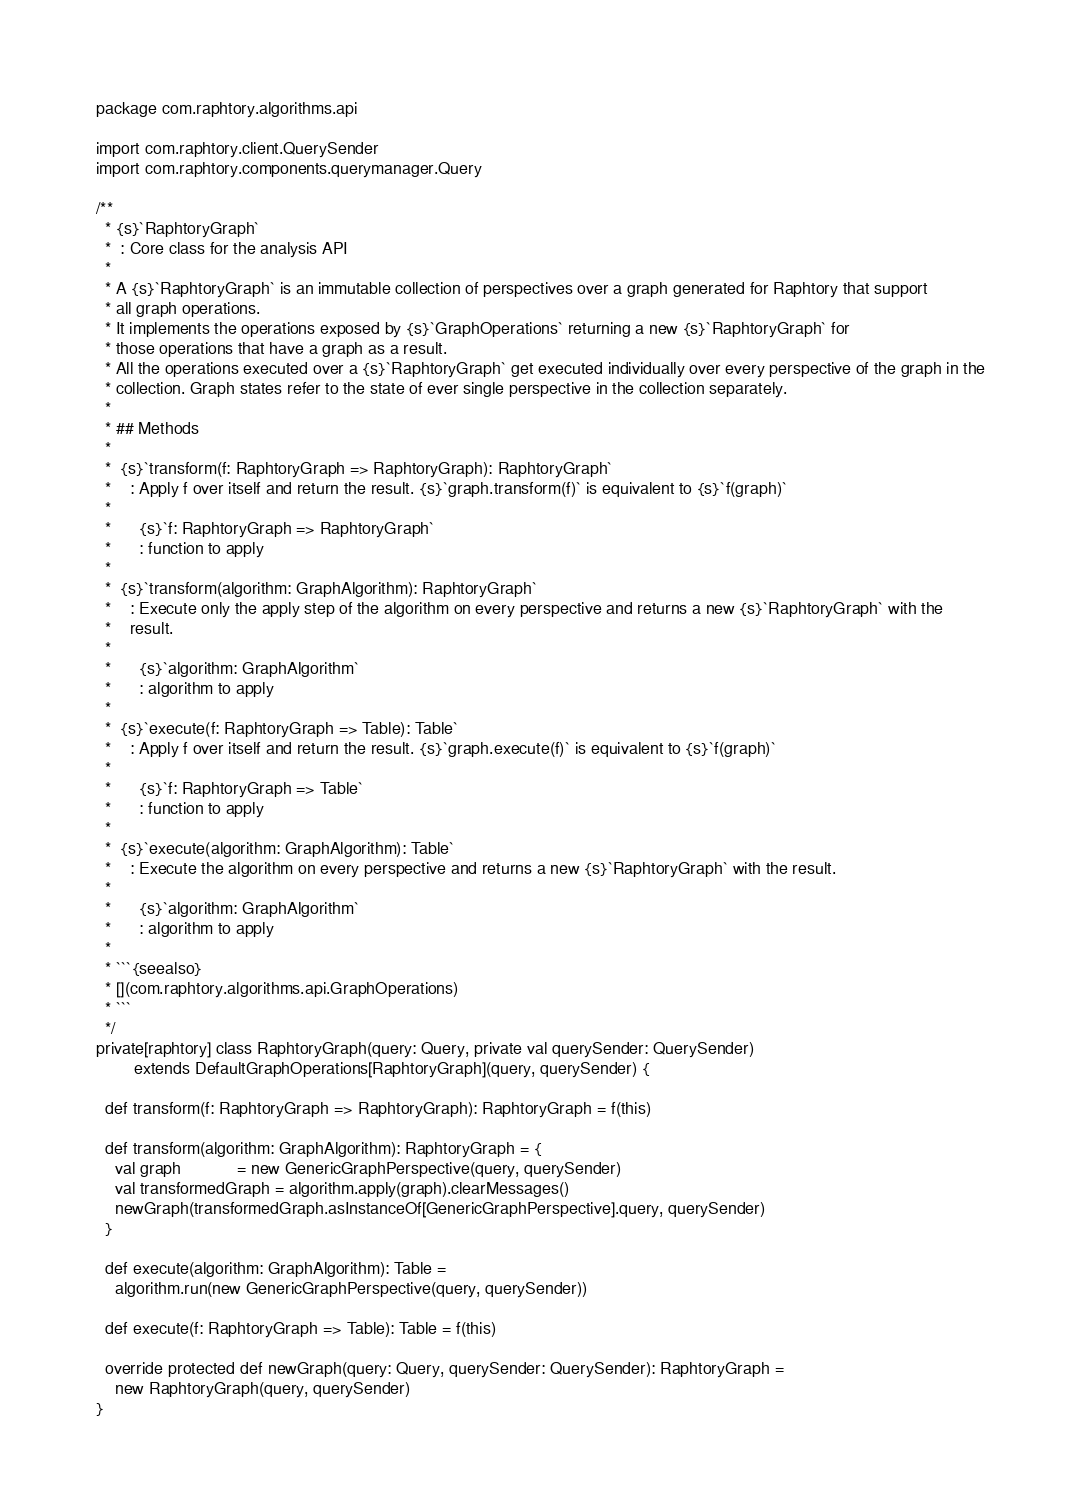<code> <loc_0><loc_0><loc_500><loc_500><_Scala_>package com.raphtory.algorithms.api

import com.raphtory.client.QuerySender
import com.raphtory.components.querymanager.Query

/**
  * {s}`RaphtoryGraph`
  *  : Core class for the analysis API
  *
  * A {s}`RaphtoryGraph` is an immutable collection of perspectives over a graph generated for Raphtory that support
  * all graph operations.
  * It implements the operations exposed by {s}`GraphOperations` returning a new {s}`RaphtoryGraph` for
  * those operations that have a graph as a result.
  * All the operations executed over a {s}`RaphtoryGraph` get executed individually over every perspective of the graph in the
  * collection. Graph states refer to the state of ever single perspective in the collection separately.
  *
  * ## Methods
  *
  *  {s}`transform(f: RaphtoryGraph => RaphtoryGraph): RaphtoryGraph`
  *    : Apply f over itself and return the result. {s}`graph.transform(f)` is equivalent to {s}`f(graph)`
  *
  *      {s}`f: RaphtoryGraph => RaphtoryGraph`
  *      : function to apply
  *
  *  {s}`transform(algorithm: GraphAlgorithm): RaphtoryGraph`
  *    : Execute only the apply step of the algorithm on every perspective and returns a new {s}`RaphtoryGraph` with the
  *    result.
  *
  *      {s}`algorithm: GraphAlgorithm`
  *      : algorithm to apply
  *
  *  {s}`execute(f: RaphtoryGraph => Table): Table`
  *    : Apply f over itself and return the result. {s}`graph.execute(f)` is equivalent to {s}`f(graph)`
  *
  *      {s}`f: RaphtoryGraph => Table`
  *      : function to apply
  *
  *  {s}`execute(algorithm: GraphAlgorithm): Table`
  *    : Execute the algorithm on every perspective and returns a new {s}`RaphtoryGraph` with the result.
  *
  *      {s}`algorithm: GraphAlgorithm`
  *      : algorithm to apply
  *
  * ```{seealso}
  * [](com.raphtory.algorithms.api.GraphOperations)
  * ```
  */
private[raphtory] class RaphtoryGraph(query: Query, private val querySender: QuerySender)
        extends DefaultGraphOperations[RaphtoryGraph](query, querySender) {

  def transform(f: RaphtoryGraph => RaphtoryGraph): RaphtoryGraph = f(this)

  def transform(algorithm: GraphAlgorithm): RaphtoryGraph = {
    val graph            = new GenericGraphPerspective(query, querySender)
    val transformedGraph = algorithm.apply(graph).clearMessages()
    newGraph(transformedGraph.asInstanceOf[GenericGraphPerspective].query, querySender)
  }

  def execute(algorithm: GraphAlgorithm): Table =
    algorithm.run(new GenericGraphPerspective(query, querySender))

  def execute(f: RaphtoryGraph => Table): Table = f(this)

  override protected def newGraph(query: Query, querySender: QuerySender): RaphtoryGraph =
    new RaphtoryGraph(query, querySender)
}
</code> 